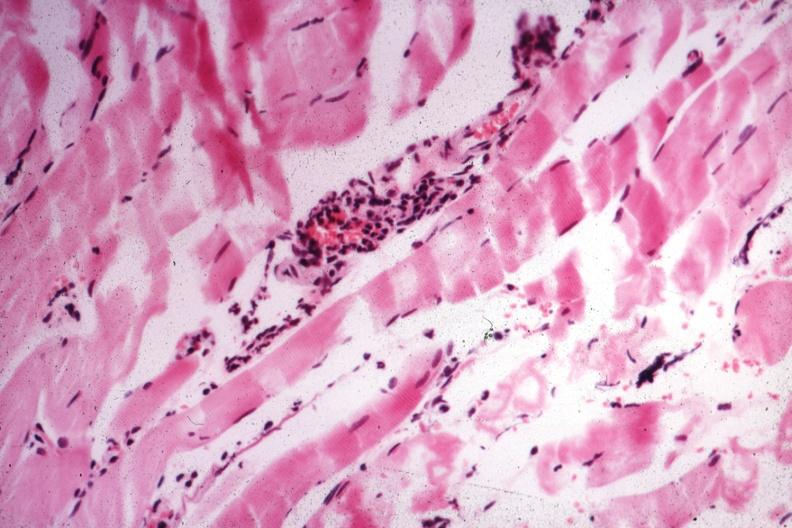what does this image show?
Answer the question using a single word or phrase. Small lymphorrhages 